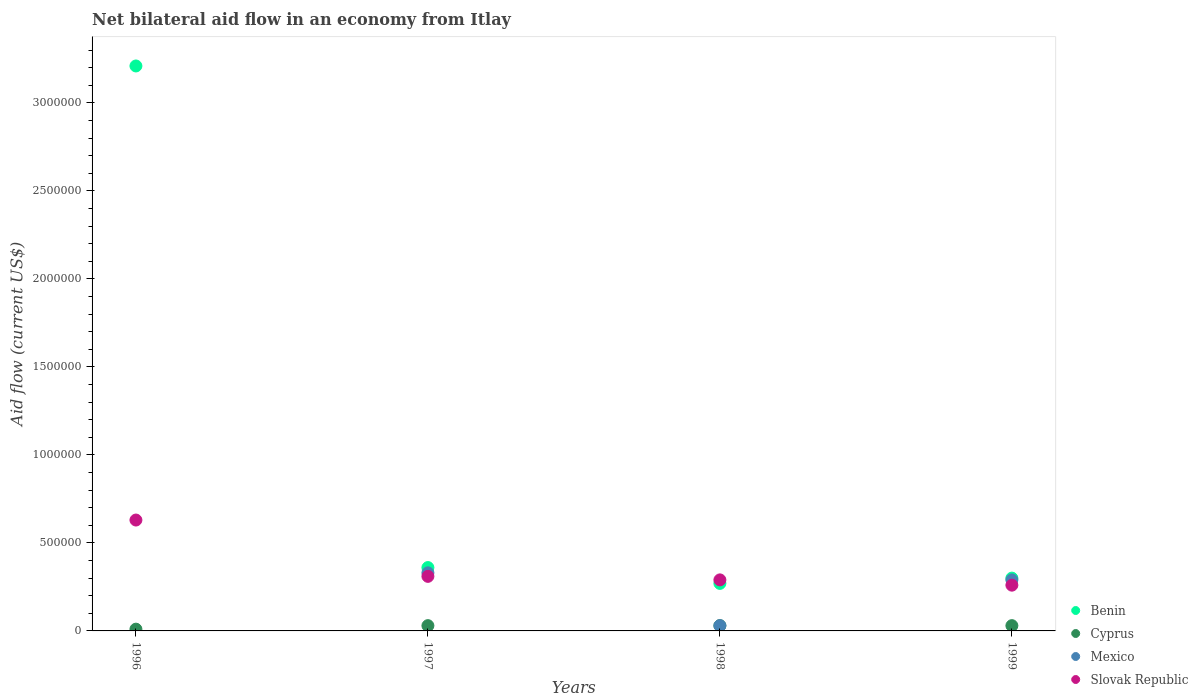Is the number of dotlines equal to the number of legend labels?
Offer a very short reply. No. Across all years, what is the maximum net bilateral aid flow in Slovak Republic?
Provide a short and direct response. 6.30e+05. What is the total net bilateral aid flow in Slovak Republic in the graph?
Give a very brief answer. 1.49e+06. What is the difference between the net bilateral aid flow in Benin in 1996 and that in 1998?
Give a very brief answer. 2.94e+06. What is the average net bilateral aid flow in Benin per year?
Give a very brief answer. 1.04e+06. What is the ratio of the net bilateral aid flow in Benin in 1997 to that in 1998?
Provide a short and direct response. 1.33. Is the difference between the net bilateral aid flow in Slovak Republic in 1996 and 1997 greater than the difference between the net bilateral aid flow in Cyprus in 1996 and 1997?
Provide a short and direct response. Yes. What is the difference between the highest and the second highest net bilateral aid flow in Mexico?
Offer a very short reply. 4.00e+04. Is the sum of the net bilateral aid flow in Benin in 1996 and 1998 greater than the maximum net bilateral aid flow in Cyprus across all years?
Your response must be concise. Yes. Is it the case that in every year, the sum of the net bilateral aid flow in Cyprus and net bilateral aid flow in Benin  is greater than the net bilateral aid flow in Mexico?
Offer a very short reply. Yes. Does the net bilateral aid flow in Cyprus monotonically increase over the years?
Provide a short and direct response. No. Is the net bilateral aid flow in Benin strictly greater than the net bilateral aid flow in Mexico over the years?
Keep it short and to the point. Yes. How many dotlines are there?
Give a very brief answer. 4. How many years are there in the graph?
Give a very brief answer. 4. Does the graph contain any zero values?
Give a very brief answer. Yes. What is the title of the graph?
Provide a succinct answer. Net bilateral aid flow in an economy from Itlay. Does "Azerbaijan" appear as one of the legend labels in the graph?
Offer a very short reply. No. What is the label or title of the X-axis?
Provide a succinct answer. Years. What is the label or title of the Y-axis?
Your answer should be very brief. Aid flow (current US$). What is the Aid flow (current US$) in Benin in 1996?
Your answer should be very brief. 3.21e+06. What is the Aid flow (current US$) in Cyprus in 1996?
Offer a terse response. 10000. What is the Aid flow (current US$) of Slovak Republic in 1996?
Offer a very short reply. 6.30e+05. What is the Aid flow (current US$) in Benin in 1997?
Offer a terse response. 3.60e+05. What is the Aid flow (current US$) of Cyprus in 1997?
Your answer should be very brief. 3.00e+04. What is the Aid flow (current US$) of Mexico in 1997?
Give a very brief answer. 3.30e+05. What is the Aid flow (current US$) of Benin in 1998?
Your answer should be compact. 2.70e+05. What is the Aid flow (current US$) in Cyprus in 1998?
Make the answer very short. 3.00e+04. What is the Aid flow (current US$) in Mexico in 1998?
Your answer should be compact. 3.00e+04. What is the Aid flow (current US$) of Slovak Republic in 1998?
Provide a short and direct response. 2.90e+05. What is the Aid flow (current US$) in Benin in 1999?
Make the answer very short. 3.00e+05. What is the Aid flow (current US$) in Slovak Republic in 1999?
Your answer should be compact. 2.60e+05. Across all years, what is the maximum Aid flow (current US$) in Benin?
Your response must be concise. 3.21e+06. Across all years, what is the maximum Aid flow (current US$) in Cyprus?
Offer a very short reply. 3.00e+04. Across all years, what is the maximum Aid flow (current US$) in Mexico?
Provide a succinct answer. 3.30e+05. Across all years, what is the maximum Aid flow (current US$) in Slovak Republic?
Make the answer very short. 6.30e+05. Across all years, what is the minimum Aid flow (current US$) in Benin?
Provide a succinct answer. 2.70e+05. Across all years, what is the minimum Aid flow (current US$) of Cyprus?
Offer a terse response. 10000. What is the total Aid flow (current US$) in Benin in the graph?
Provide a short and direct response. 4.14e+06. What is the total Aid flow (current US$) of Cyprus in the graph?
Provide a short and direct response. 1.00e+05. What is the total Aid flow (current US$) of Mexico in the graph?
Provide a short and direct response. 6.50e+05. What is the total Aid flow (current US$) of Slovak Republic in the graph?
Your answer should be compact. 1.49e+06. What is the difference between the Aid flow (current US$) of Benin in 1996 and that in 1997?
Your answer should be very brief. 2.85e+06. What is the difference between the Aid flow (current US$) of Cyprus in 1996 and that in 1997?
Give a very brief answer. -2.00e+04. What is the difference between the Aid flow (current US$) of Benin in 1996 and that in 1998?
Keep it short and to the point. 2.94e+06. What is the difference between the Aid flow (current US$) of Benin in 1996 and that in 1999?
Your answer should be compact. 2.91e+06. What is the difference between the Aid flow (current US$) of Slovak Republic in 1996 and that in 1999?
Give a very brief answer. 3.70e+05. What is the difference between the Aid flow (current US$) of Benin in 1997 and that in 1998?
Make the answer very short. 9.00e+04. What is the difference between the Aid flow (current US$) in Cyprus in 1997 and that in 1998?
Provide a succinct answer. 0. What is the difference between the Aid flow (current US$) of Mexico in 1997 and that in 1998?
Your answer should be very brief. 3.00e+05. What is the difference between the Aid flow (current US$) of Slovak Republic in 1997 and that in 1998?
Provide a succinct answer. 2.00e+04. What is the difference between the Aid flow (current US$) of Benin in 1997 and that in 1999?
Offer a very short reply. 6.00e+04. What is the difference between the Aid flow (current US$) in Benin in 1998 and that in 1999?
Provide a succinct answer. -3.00e+04. What is the difference between the Aid flow (current US$) in Benin in 1996 and the Aid flow (current US$) in Cyprus in 1997?
Make the answer very short. 3.18e+06. What is the difference between the Aid flow (current US$) in Benin in 1996 and the Aid flow (current US$) in Mexico in 1997?
Provide a short and direct response. 2.88e+06. What is the difference between the Aid flow (current US$) in Benin in 1996 and the Aid flow (current US$) in Slovak Republic in 1997?
Provide a succinct answer. 2.90e+06. What is the difference between the Aid flow (current US$) of Cyprus in 1996 and the Aid flow (current US$) of Mexico in 1997?
Your response must be concise. -3.20e+05. What is the difference between the Aid flow (current US$) of Benin in 1996 and the Aid flow (current US$) of Cyprus in 1998?
Keep it short and to the point. 3.18e+06. What is the difference between the Aid flow (current US$) of Benin in 1996 and the Aid flow (current US$) of Mexico in 1998?
Provide a succinct answer. 3.18e+06. What is the difference between the Aid flow (current US$) of Benin in 1996 and the Aid flow (current US$) of Slovak Republic in 1998?
Provide a short and direct response. 2.92e+06. What is the difference between the Aid flow (current US$) in Cyprus in 1996 and the Aid flow (current US$) in Mexico in 1998?
Provide a short and direct response. -2.00e+04. What is the difference between the Aid flow (current US$) in Cyprus in 1996 and the Aid flow (current US$) in Slovak Republic in 1998?
Offer a terse response. -2.80e+05. What is the difference between the Aid flow (current US$) in Benin in 1996 and the Aid flow (current US$) in Cyprus in 1999?
Your answer should be very brief. 3.18e+06. What is the difference between the Aid flow (current US$) in Benin in 1996 and the Aid flow (current US$) in Mexico in 1999?
Your response must be concise. 2.92e+06. What is the difference between the Aid flow (current US$) of Benin in 1996 and the Aid flow (current US$) of Slovak Republic in 1999?
Offer a very short reply. 2.95e+06. What is the difference between the Aid flow (current US$) in Cyprus in 1996 and the Aid flow (current US$) in Mexico in 1999?
Your response must be concise. -2.80e+05. What is the difference between the Aid flow (current US$) of Benin in 1997 and the Aid flow (current US$) of Mexico in 1998?
Your response must be concise. 3.30e+05. What is the difference between the Aid flow (current US$) in Cyprus in 1997 and the Aid flow (current US$) in Mexico in 1998?
Ensure brevity in your answer.  0. What is the difference between the Aid flow (current US$) of Cyprus in 1997 and the Aid flow (current US$) of Slovak Republic in 1998?
Give a very brief answer. -2.60e+05. What is the difference between the Aid flow (current US$) of Benin in 1997 and the Aid flow (current US$) of Mexico in 1999?
Give a very brief answer. 7.00e+04. What is the difference between the Aid flow (current US$) of Benin in 1997 and the Aid flow (current US$) of Slovak Republic in 1999?
Provide a succinct answer. 1.00e+05. What is the difference between the Aid flow (current US$) in Cyprus in 1997 and the Aid flow (current US$) in Slovak Republic in 1999?
Make the answer very short. -2.30e+05. What is the difference between the Aid flow (current US$) in Benin in 1998 and the Aid flow (current US$) in Cyprus in 1999?
Your response must be concise. 2.40e+05. What is the difference between the Aid flow (current US$) in Benin in 1998 and the Aid flow (current US$) in Slovak Republic in 1999?
Provide a succinct answer. 10000. What is the difference between the Aid flow (current US$) in Mexico in 1998 and the Aid flow (current US$) in Slovak Republic in 1999?
Offer a terse response. -2.30e+05. What is the average Aid flow (current US$) of Benin per year?
Provide a short and direct response. 1.04e+06. What is the average Aid flow (current US$) in Cyprus per year?
Your response must be concise. 2.50e+04. What is the average Aid flow (current US$) of Mexico per year?
Your answer should be very brief. 1.62e+05. What is the average Aid flow (current US$) in Slovak Republic per year?
Offer a very short reply. 3.72e+05. In the year 1996, what is the difference between the Aid flow (current US$) of Benin and Aid flow (current US$) of Cyprus?
Provide a short and direct response. 3.20e+06. In the year 1996, what is the difference between the Aid flow (current US$) in Benin and Aid flow (current US$) in Slovak Republic?
Your answer should be compact. 2.58e+06. In the year 1996, what is the difference between the Aid flow (current US$) in Cyprus and Aid flow (current US$) in Slovak Republic?
Offer a terse response. -6.20e+05. In the year 1997, what is the difference between the Aid flow (current US$) of Cyprus and Aid flow (current US$) of Slovak Republic?
Your answer should be compact. -2.80e+05. In the year 1998, what is the difference between the Aid flow (current US$) in Benin and Aid flow (current US$) in Cyprus?
Ensure brevity in your answer.  2.40e+05. In the year 1998, what is the difference between the Aid flow (current US$) of Cyprus and Aid flow (current US$) of Mexico?
Keep it short and to the point. 0. In the year 1998, what is the difference between the Aid flow (current US$) of Cyprus and Aid flow (current US$) of Slovak Republic?
Keep it short and to the point. -2.60e+05. In the year 1999, what is the difference between the Aid flow (current US$) of Benin and Aid flow (current US$) of Mexico?
Your response must be concise. 10000. In the year 1999, what is the difference between the Aid flow (current US$) of Cyprus and Aid flow (current US$) of Mexico?
Your response must be concise. -2.60e+05. In the year 1999, what is the difference between the Aid flow (current US$) in Cyprus and Aid flow (current US$) in Slovak Republic?
Offer a very short reply. -2.30e+05. In the year 1999, what is the difference between the Aid flow (current US$) of Mexico and Aid flow (current US$) of Slovak Republic?
Ensure brevity in your answer.  3.00e+04. What is the ratio of the Aid flow (current US$) of Benin in 1996 to that in 1997?
Provide a succinct answer. 8.92. What is the ratio of the Aid flow (current US$) of Slovak Republic in 1996 to that in 1997?
Your answer should be compact. 2.03. What is the ratio of the Aid flow (current US$) of Benin in 1996 to that in 1998?
Give a very brief answer. 11.89. What is the ratio of the Aid flow (current US$) of Cyprus in 1996 to that in 1998?
Give a very brief answer. 0.33. What is the ratio of the Aid flow (current US$) in Slovak Republic in 1996 to that in 1998?
Provide a short and direct response. 2.17. What is the ratio of the Aid flow (current US$) in Cyprus in 1996 to that in 1999?
Keep it short and to the point. 0.33. What is the ratio of the Aid flow (current US$) of Slovak Republic in 1996 to that in 1999?
Your answer should be compact. 2.42. What is the ratio of the Aid flow (current US$) in Benin in 1997 to that in 1998?
Your answer should be very brief. 1.33. What is the ratio of the Aid flow (current US$) of Slovak Republic in 1997 to that in 1998?
Provide a succinct answer. 1.07. What is the ratio of the Aid flow (current US$) in Mexico in 1997 to that in 1999?
Make the answer very short. 1.14. What is the ratio of the Aid flow (current US$) in Slovak Republic in 1997 to that in 1999?
Offer a terse response. 1.19. What is the ratio of the Aid flow (current US$) of Benin in 1998 to that in 1999?
Your answer should be compact. 0.9. What is the ratio of the Aid flow (current US$) in Mexico in 1998 to that in 1999?
Give a very brief answer. 0.1. What is the ratio of the Aid flow (current US$) of Slovak Republic in 1998 to that in 1999?
Provide a succinct answer. 1.12. What is the difference between the highest and the second highest Aid flow (current US$) in Benin?
Keep it short and to the point. 2.85e+06. What is the difference between the highest and the second highest Aid flow (current US$) of Cyprus?
Offer a terse response. 0. What is the difference between the highest and the second highest Aid flow (current US$) in Mexico?
Your answer should be very brief. 4.00e+04. What is the difference between the highest and the second highest Aid flow (current US$) of Slovak Republic?
Make the answer very short. 3.20e+05. What is the difference between the highest and the lowest Aid flow (current US$) of Benin?
Keep it short and to the point. 2.94e+06. What is the difference between the highest and the lowest Aid flow (current US$) of Slovak Republic?
Offer a terse response. 3.70e+05. 